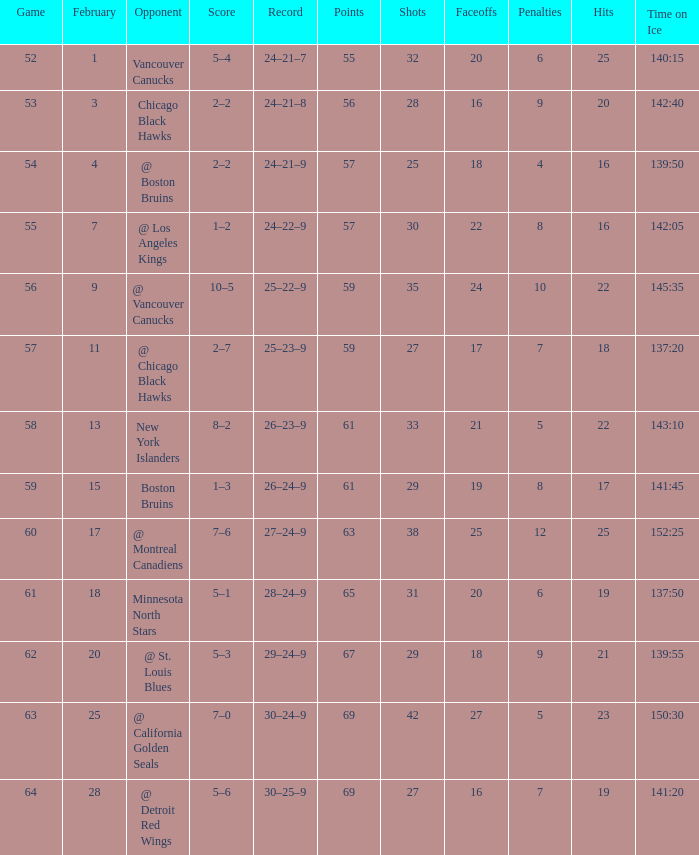How many games have a record of 30–25–9 and more points than 69? 0.0. 